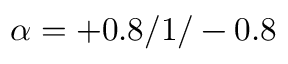<formula> <loc_0><loc_0><loc_500><loc_500>\alpha = + 0 . 8 / 1 / - 0 . 8</formula> 